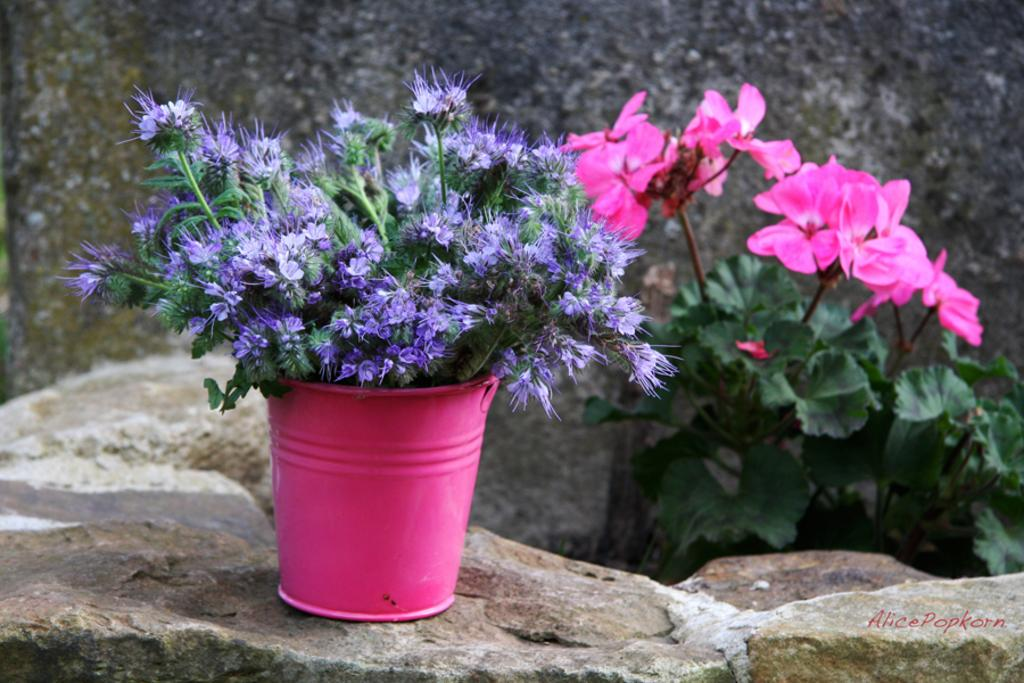What is the main subject of the image? There is a plant with flowers in a bucket on a stone in the image. Are there any other plants with flowers in the image? Yes, there is another plant with flowers on the right side. What can be seen in the background of the image? There is a wall visible in the background. What type of beam is holding the attention of the flowers in the image? There is no beam present in the image, and the flowers are not shown to be holding any attention. 